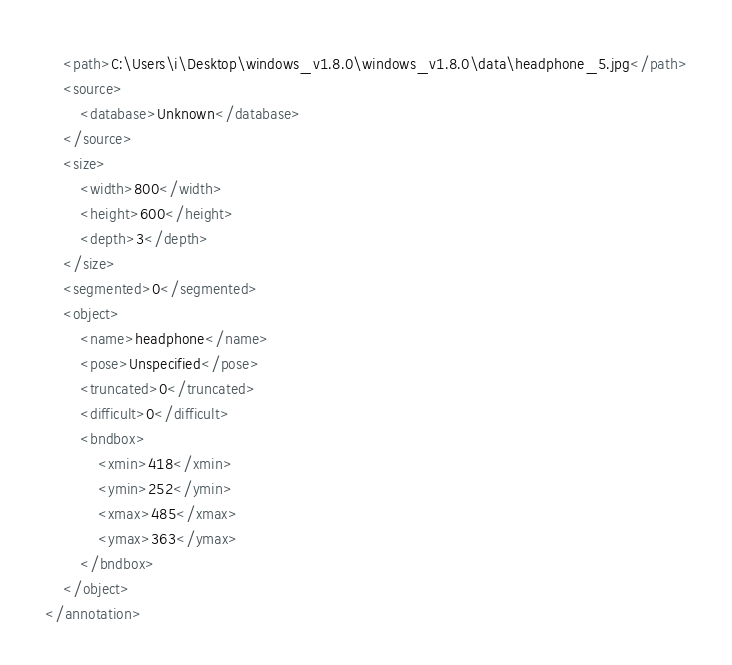Convert code to text. <code><loc_0><loc_0><loc_500><loc_500><_XML_>	<path>C:\Users\i\Desktop\windows_v1.8.0\windows_v1.8.0\data\headphone_5.jpg</path>
	<source>
		<database>Unknown</database>
	</source>
	<size>
		<width>800</width>
		<height>600</height>
		<depth>3</depth>
	</size>
	<segmented>0</segmented>
	<object>
		<name>headphone</name>
		<pose>Unspecified</pose>
		<truncated>0</truncated>
		<difficult>0</difficult>
		<bndbox>
			<xmin>418</xmin>
			<ymin>252</ymin>
			<xmax>485</xmax>
			<ymax>363</ymax>
		</bndbox>
	</object>
</annotation>
</code> 